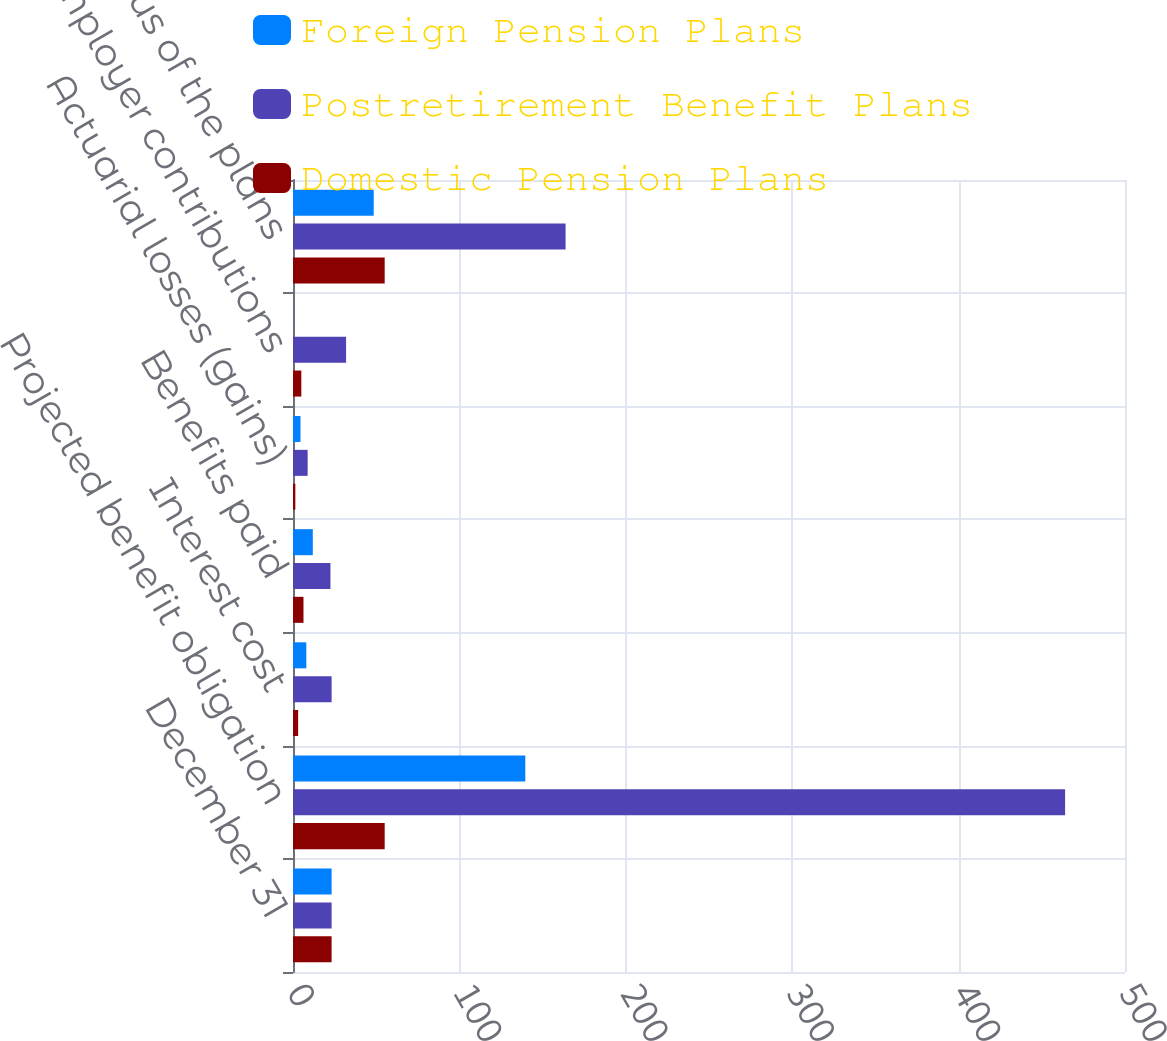<chart> <loc_0><loc_0><loc_500><loc_500><stacked_bar_chart><ecel><fcel>December 31<fcel>Projected benefit obligation<fcel>Interest cost<fcel>Benefits paid<fcel>Actuarial losses (gains)<fcel>Employer contributions<fcel>Funded status of the plans<nl><fcel>Foreign Pension Plans<fcel>23.2<fcel>139.6<fcel>8<fcel>11.9<fcel>4.5<fcel>0.1<fcel>48.5<nl><fcel>Postretirement Benefit Plans<fcel>23.2<fcel>464<fcel>23.2<fcel>22.5<fcel>8.8<fcel>31.9<fcel>163.8<nl><fcel>Domestic Pension Plans<fcel>23.2<fcel>55.1<fcel>3.1<fcel>6.3<fcel>1.4<fcel>5<fcel>55.1<nl></chart> 